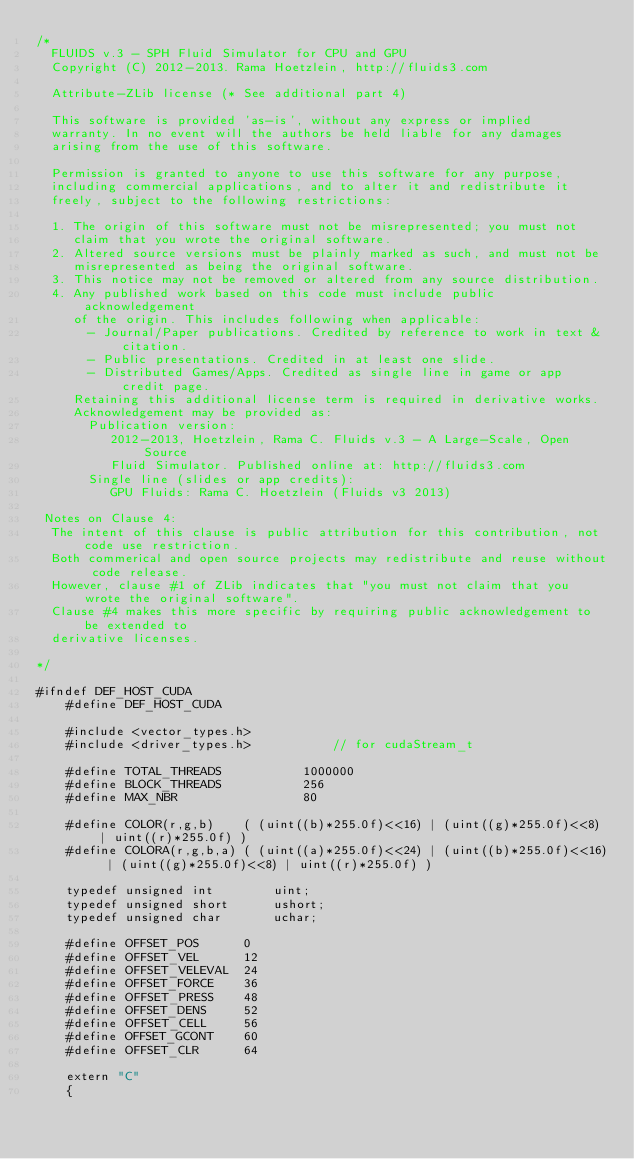<code> <loc_0><loc_0><loc_500><loc_500><_Cuda_>/*
  FLUIDS v.3 - SPH Fluid Simulator for CPU and GPU
  Copyright (C) 2012-2013. Rama Hoetzlein, http://fluids3.com

  Attribute-ZLib license (* See additional part 4)

  This software is provided 'as-is', without any express or implied
  warranty. In no event will the authors be held liable for any damages
  arising from the use of this software.

  Permission is granted to anyone to use this software for any purpose,
  including commercial applications, and to alter it and redistribute it
  freely, subject to the following restrictions:

  1. The origin of this software must not be misrepresented; you must not
     claim that you wrote the original software.
  2. Altered source versions must be plainly marked as such, and must not be
     misrepresented as being the original software.
  3. This notice may not be removed or altered from any source distribution.
  4. Any published work based on this code must include public acknowledgement
     of the origin. This includes following when applicable:
	   - Journal/Paper publications. Credited by reference to work in text & citation.
	   - Public presentations. Credited in at least one slide.
	   - Distributed Games/Apps. Credited as single line in game or app credit page.	 
	 Retaining this additional license term is required in derivative works.
	 Acknowledgement may be provided as:
	   Publication version:  
	      2012-2013, Hoetzlein, Rama C. Fluids v.3 - A Large-Scale, Open Source
	 	  Fluid Simulator. Published online at: http://fluids3.com
	   Single line (slides or app credits):
	      GPU Fluids: Rama C. Hoetzlein (Fluids v3 2013)

 Notes on Clause 4:
  The intent of this clause is public attribution for this contribution, not code use restriction. 
  Both commerical and open source projects may redistribute and reuse without code release.
  However, clause #1 of ZLib indicates that "you must not claim that you wrote the original software". 
  Clause #4 makes this more specific by requiring public acknowledgement to be extended to 
  derivative licenses. 

*/

#ifndef DEF_HOST_CUDA
	#define DEF_HOST_CUDA

	#include <vector_types.h>
	#include <driver_types.h>			// for cudaStream_t

	#define TOTAL_THREADS			1000000
	#define BLOCK_THREADS			256
	#define MAX_NBR					80	
	
	#define COLOR(r,g,b)	( (uint((b)*255.0f)<<16) | (uint((g)*255.0f)<<8) | uint((r)*255.0f) )
	#define COLORA(r,g,b,a)	( (uint((a)*255.0f)<<24) | (uint((b)*255.0f)<<16) | (uint((g)*255.0f)<<8) | uint((r)*255.0f) )

	typedef unsigned int		uint;
	typedef unsigned short		ushort;
	typedef unsigned char		uchar;

	#define OFFSET_POS		0
	#define OFFSET_VEL		12
	#define OFFSET_VELEVAL	24
	#define OFFSET_FORCE	36
	#define OFFSET_PRESS	48
	#define OFFSET_DENS		52
	#define OFFSET_CELL		56
	#define OFFSET_GCONT	60
	#define OFFSET_CLR		64

	extern "C"
	{
</code> 